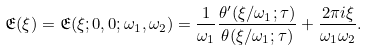<formula> <loc_0><loc_0><loc_500><loc_500>\mathfrak { E } ( \xi ) = \mathfrak { E } ( \xi ; 0 , 0 ; \omega _ { 1 } , \omega _ { 2 } ) = \frac { 1 } { \omega _ { 1 } } \frac { \theta ^ { \prime } ( \xi / \omega _ { 1 } ; \tau ) } { \theta ( \xi / \omega _ { 1 } ; \tau ) } + \frac { 2 \pi i \xi } { \omega _ { 1 } \omega _ { 2 } } .</formula> 